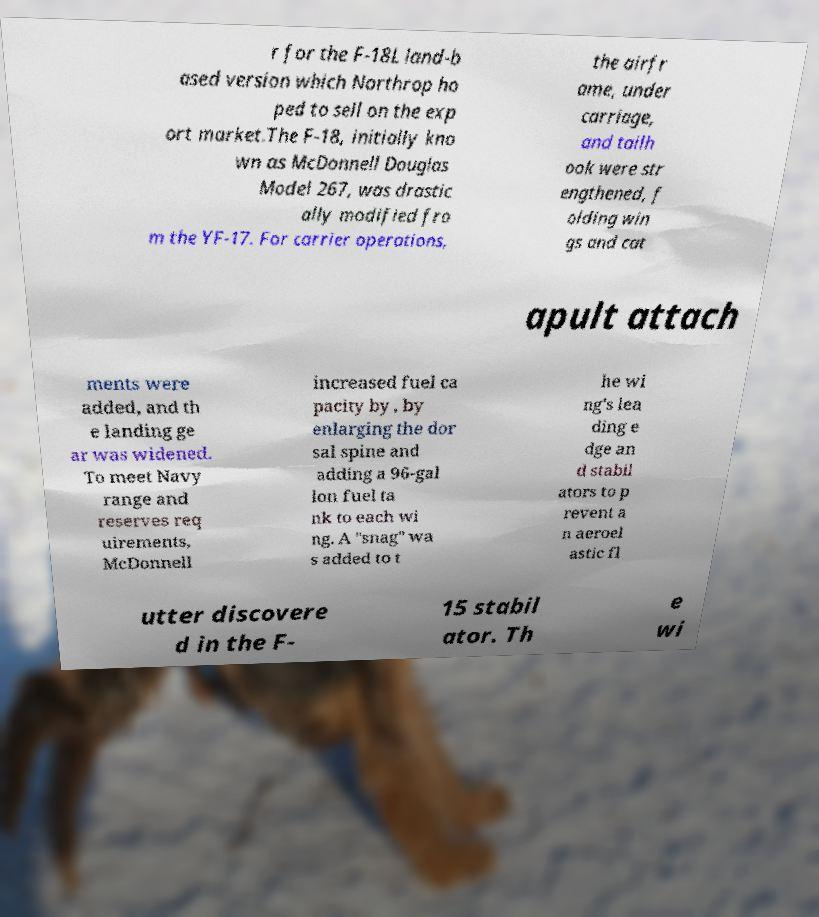Please identify and transcribe the text found in this image. r for the F-18L land-b ased version which Northrop ho ped to sell on the exp ort market.The F-18, initially kno wn as McDonnell Douglas Model 267, was drastic ally modified fro m the YF-17. For carrier operations, the airfr ame, under carriage, and tailh ook were str engthened, f olding win gs and cat apult attach ments were added, and th e landing ge ar was widened. To meet Navy range and reserves req uirements, McDonnell increased fuel ca pacity by , by enlarging the dor sal spine and adding a 96-gal lon fuel ta nk to each wi ng. A "snag" wa s added to t he wi ng's lea ding e dge an d stabil ators to p revent a n aeroel astic fl utter discovere d in the F- 15 stabil ator. Th e wi 